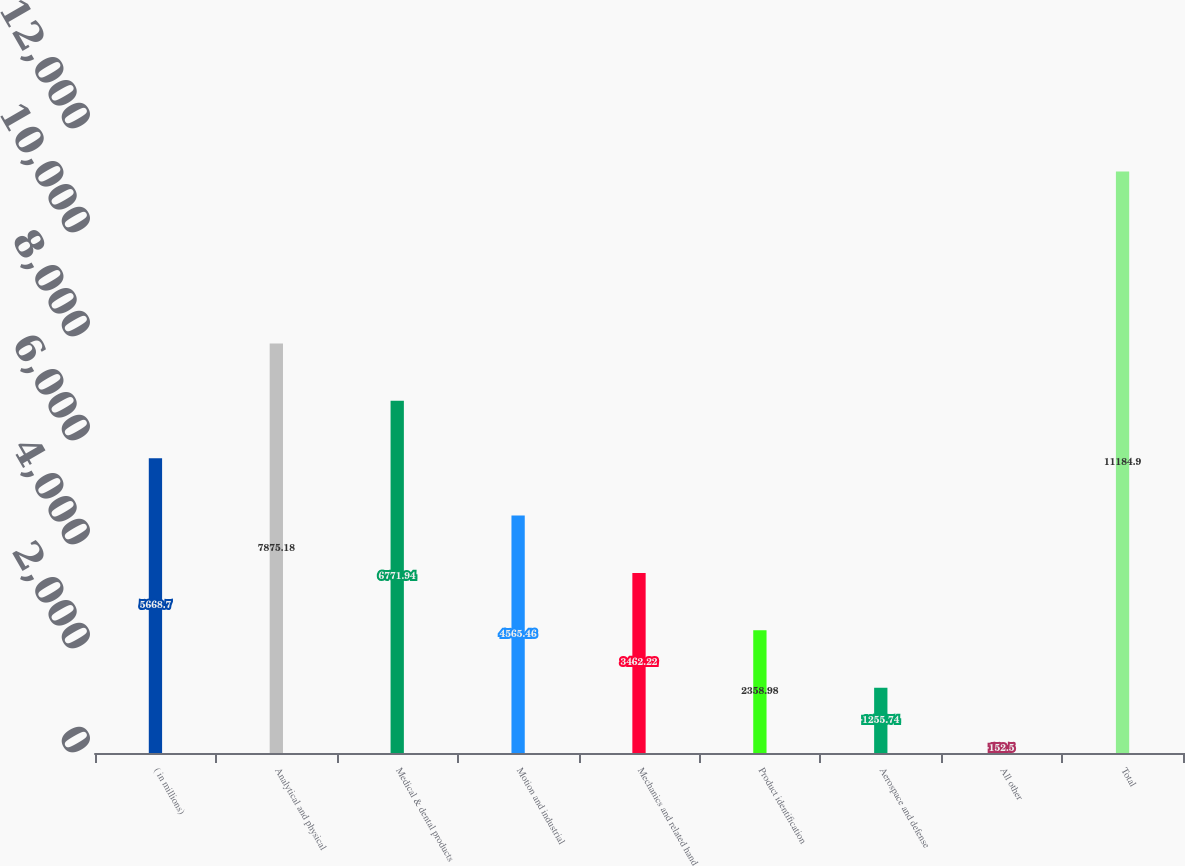Convert chart to OTSL. <chart><loc_0><loc_0><loc_500><loc_500><bar_chart><fcel>( in millions)<fcel>Analytical and physical<fcel>Medical & dental products<fcel>Motion and industrial<fcel>Mechanics and related hand<fcel>Product identification<fcel>Aerospace and defense<fcel>All other<fcel>Total<nl><fcel>5668.7<fcel>7875.18<fcel>6771.94<fcel>4565.46<fcel>3462.22<fcel>2358.98<fcel>1255.74<fcel>152.5<fcel>11184.9<nl></chart> 